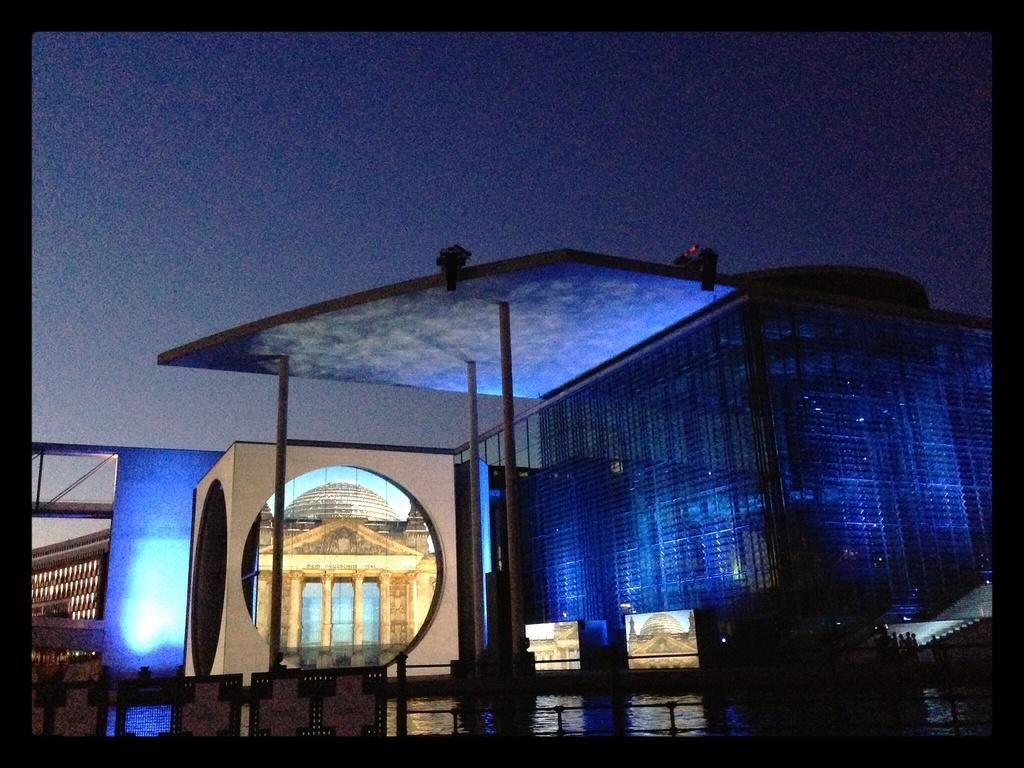What is the main structure visible in the image? There is a huge building with pillars in the image. What is located in front of the building? There is a water lake in front of the building. What type of stem can be seen growing from the building in the image? There is no stem growing from the building in the image. What kind of locket is hanging from the pillars in the image? There is no locket present in the image. 